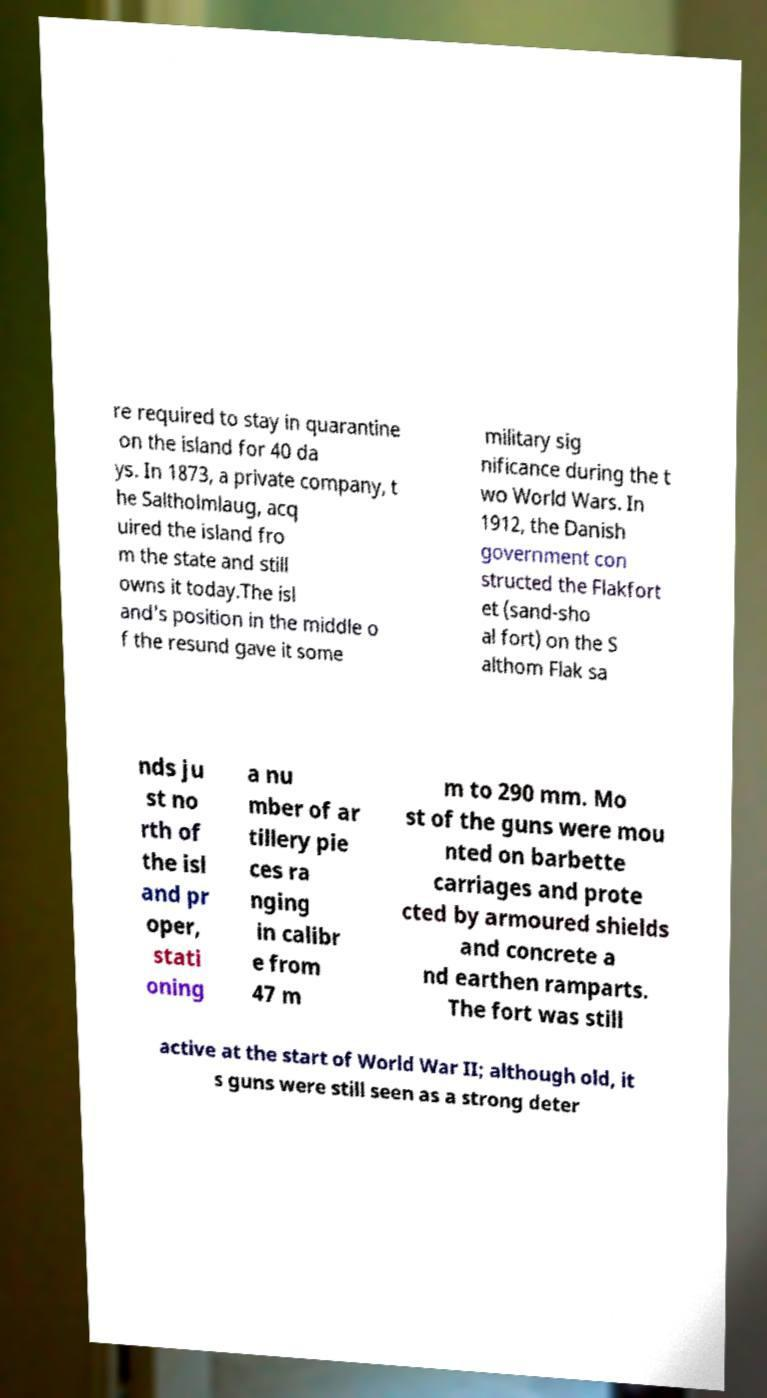Could you extract and type out the text from this image? re required to stay in quarantine on the island for 40 da ys. In 1873, a private company, t he Saltholmlaug, acq uired the island fro m the state and still owns it today.The isl and's position in the middle o f the resund gave it some military sig nificance during the t wo World Wars. In 1912, the Danish government con structed the Flakfort et (sand-sho al fort) on the S althom Flak sa nds ju st no rth of the isl and pr oper, stati oning a nu mber of ar tillery pie ces ra nging in calibr e from 47 m m to 290 mm. Mo st of the guns were mou nted on barbette carriages and prote cted by armoured shields and concrete a nd earthen ramparts. The fort was still active at the start of World War II; although old, it s guns were still seen as a strong deter 